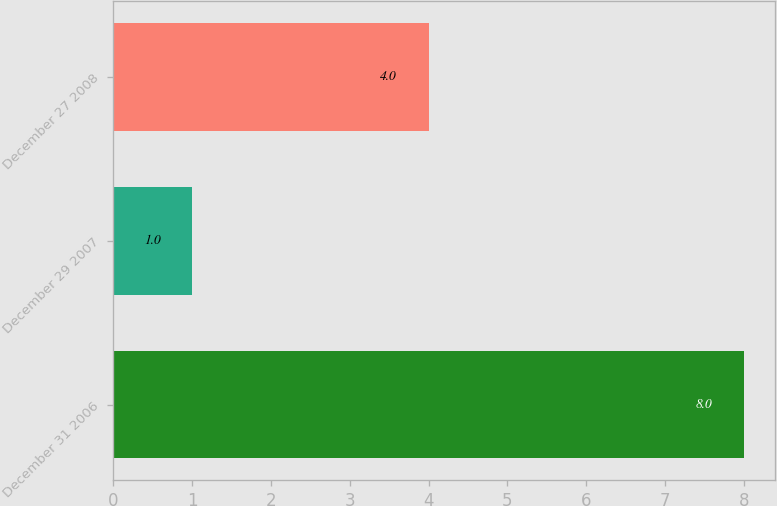<chart> <loc_0><loc_0><loc_500><loc_500><bar_chart><fcel>December 31 2006<fcel>December 29 2007<fcel>December 27 2008<nl><fcel>8<fcel>1<fcel>4<nl></chart> 